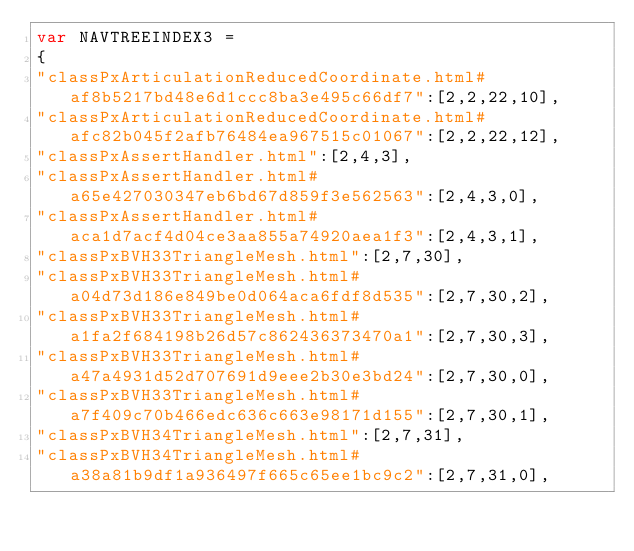<code> <loc_0><loc_0><loc_500><loc_500><_JavaScript_>var NAVTREEINDEX3 =
{
"classPxArticulationReducedCoordinate.html#af8b5217bd48e6d1ccc8ba3e495c66df7":[2,2,22,10],
"classPxArticulationReducedCoordinate.html#afc82b045f2afb76484ea967515c01067":[2,2,22,12],
"classPxAssertHandler.html":[2,4,3],
"classPxAssertHandler.html#a65e427030347eb6bd67d859f3e562563":[2,4,3,0],
"classPxAssertHandler.html#aca1d7acf4d04ce3aa855a74920aea1f3":[2,4,3,1],
"classPxBVH33TriangleMesh.html":[2,7,30],
"classPxBVH33TriangleMesh.html#a04d73d186e849be0d064aca6fdf8d535":[2,7,30,2],
"classPxBVH33TriangleMesh.html#a1fa2f684198b26d57c862436373470a1":[2,7,30,3],
"classPxBVH33TriangleMesh.html#a47a4931d52d707691d9eee2b30e3bd24":[2,7,30,0],
"classPxBVH33TriangleMesh.html#a7f409c70b466edc636c663e98171d155":[2,7,30,1],
"classPxBVH34TriangleMesh.html":[2,7,31],
"classPxBVH34TriangleMesh.html#a38a81b9df1a936497f665c65ee1bc9c2":[2,7,31,0],</code> 